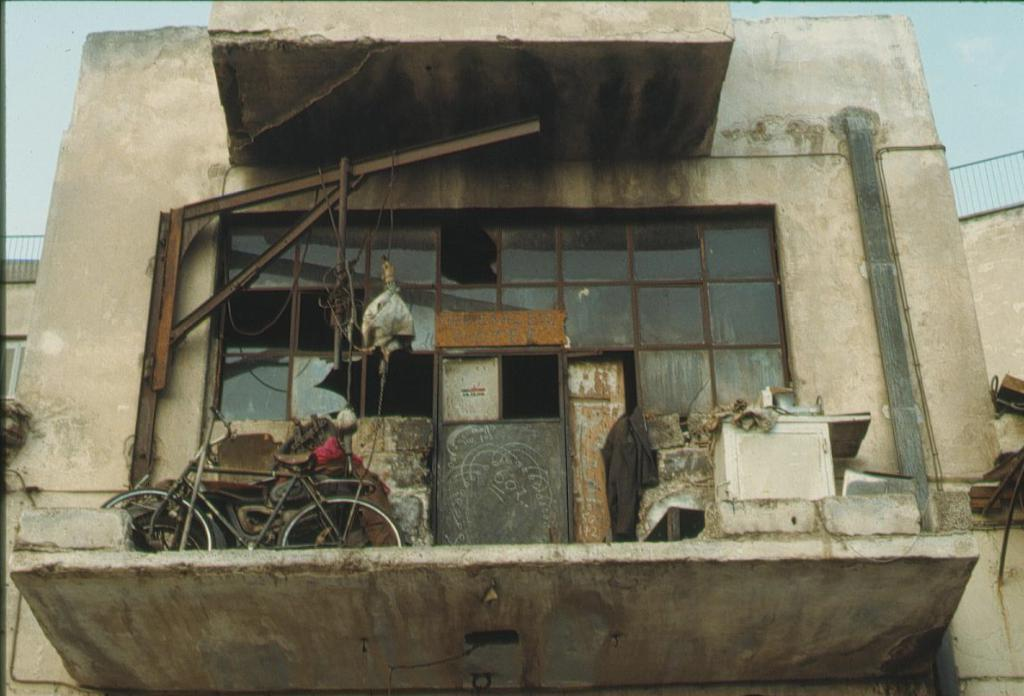What type of vehicle is in the image? There is a bicycle in the image. What structure is present in the image? There is a door and a framed glass wall in the image. What type of building is in the image? There is a building in the image. What architectural feature is in the image? There is a fence in the image. What can be seen in the background of the image? The sky is visible in the background of the image. What type of agreement is being discussed in the image? There is no indication of any agreement being discussed in the image; it primarily features a bicycle and various structures. 